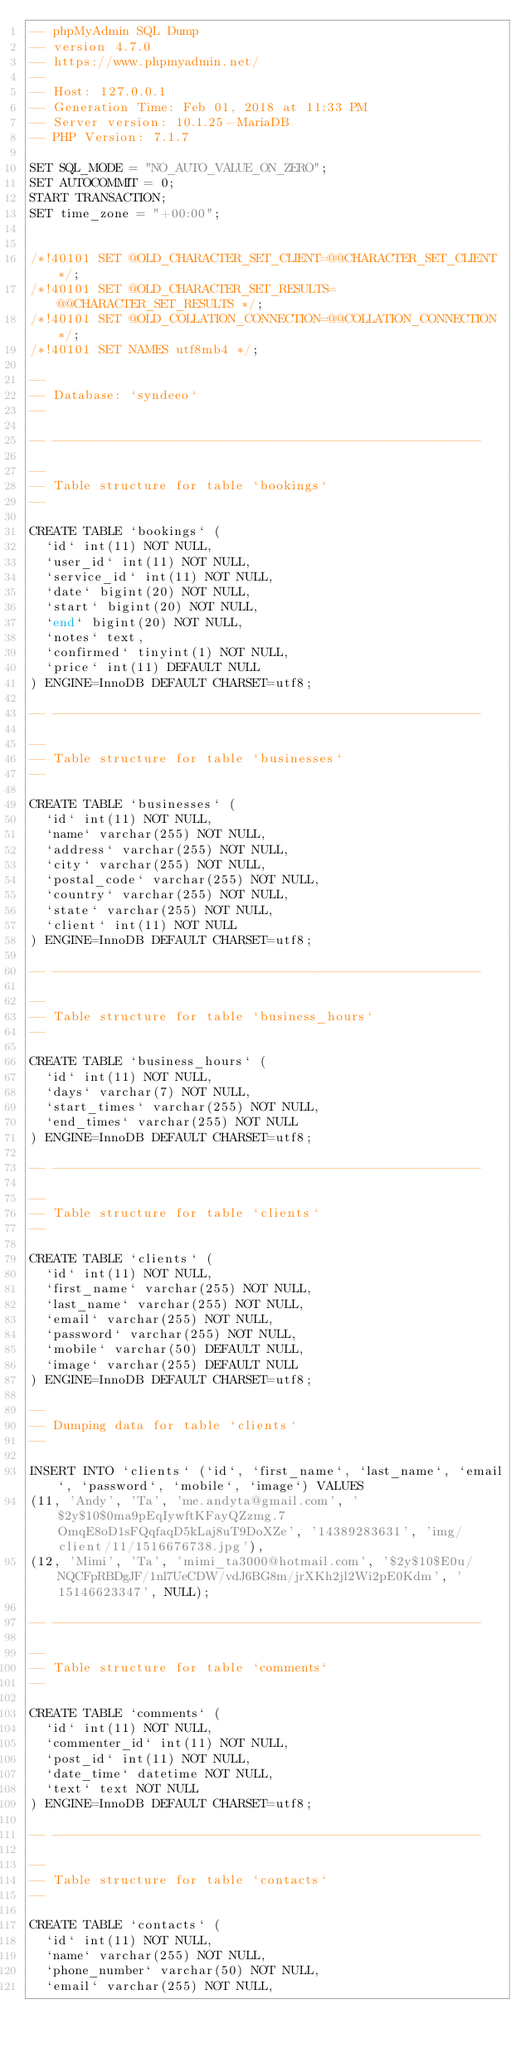Convert code to text. <code><loc_0><loc_0><loc_500><loc_500><_SQL_>-- phpMyAdmin SQL Dump
-- version 4.7.0
-- https://www.phpmyadmin.net/
--
-- Host: 127.0.0.1
-- Generation Time: Feb 01, 2018 at 11:33 PM
-- Server version: 10.1.25-MariaDB
-- PHP Version: 7.1.7

SET SQL_MODE = "NO_AUTO_VALUE_ON_ZERO";
SET AUTOCOMMIT = 0;
START TRANSACTION;
SET time_zone = "+00:00";


/*!40101 SET @OLD_CHARACTER_SET_CLIENT=@@CHARACTER_SET_CLIENT */;
/*!40101 SET @OLD_CHARACTER_SET_RESULTS=@@CHARACTER_SET_RESULTS */;
/*!40101 SET @OLD_COLLATION_CONNECTION=@@COLLATION_CONNECTION */;
/*!40101 SET NAMES utf8mb4 */;

--
-- Database: `syndeeo`
--

-- --------------------------------------------------------

--
-- Table structure for table `bookings`
--

CREATE TABLE `bookings` (
  `id` int(11) NOT NULL,
  `user_id` int(11) NOT NULL,
  `service_id` int(11) NOT NULL,
  `date` bigint(20) NOT NULL,
  `start` bigint(20) NOT NULL,
  `end` bigint(20) NOT NULL,
  `notes` text,
  `confirmed` tinyint(1) NOT NULL,
  `price` int(11) DEFAULT NULL
) ENGINE=InnoDB DEFAULT CHARSET=utf8;

-- --------------------------------------------------------

--
-- Table structure for table `businesses`
--

CREATE TABLE `businesses` (
  `id` int(11) NOT NULL,
  `name` varchar(255) NOT NULL,
  `address` varchar(255) NOT NULL,
  `city` varchar(255) NOT NULL,
  `postal_code` varchar(255) NOT NULL,
  `country` varchar(255) NOT NULL,
  `state` varchar(255) NOT NULL,
  `client` int(11) NOT NULL
) ENGINE=InnoDB DEFAULT CHARSET=utf8;

-- --------------------------------------------------------

--
-- Table structure for table `business_hours`
--

CREATE TABLE `business_hours` (
  `id` int(11) NOT NULL,
  `days` varchar(7) NOT NULL,
  `start_times` varchar(255) NOT NULL,
  `end_times` varchar(255) NOT NULL
) ENGINE=InnoDB DEFAULT CHARSET=utf8;

-- --------------------------------------------------------

--
-- Table structure for table `clients`
--

CREATE TABLE `clients` (
  `id` int(11) NOT NULL,
  `first_name` varchar(255) NOT NULL,
  `last_name` varchar(255) NOT NULL,
  `email` varchar(255) NOT NULL,
  `password` varchar(255) NOT NULL,
  `mobile` varchar(50) DEFAULT NULL,
  `image` varchar(255) DEFAULT NULL
) ENGINE=InnoDB DEFAULT CHARSET=utf8;

--
-- Dumping data for table `clients`
--

INSERT INTO `clients` (`id`, `first_name`, `last_name`, `email`, `password`, `mobile`, `image`) VALUES
(11, 'Andy', 'Ta', 'me.andyta@gmail.com', '$2y$10$0ma9pEqIywftKFayQZzmg.7OmqE8oD1sFQqfaqD5kLaj8uT9DoXZe', '14389283631', 'img/client/11/1516676738.jpg'),
(12, 'Mimi', 'Ta', 'mimi_ta3000@hotmail.com', '$2y$10$E0u/NQCFpRBDgJF/1nl7UeCDW/vdJ6BG8m/jrXKh2jl2Wi2pE0Kdm', '15146623347', NULL);

-- --------------------------------------------------------

--
-- Table structure for table `comments`
--

CREATE TABLE `comments` (
  `id` int(11) NOT NULL,
  `commenter_id` int(11) NOT NULL,
  `post_id` int(11) NOT NULL,
  `date_time` datetime NOT NULL,
  `text` text NOT NULL
) ENGINE=InnoDB DEFAULT CHARSET=utf8;

-- --------------------------------------------------------

--
-- Table structure for table `contacts`
--

CREATE TABLE `contacts` (
  `id` int(11) NOT NULL,
  `name` varchar(255) NOT NULL,
  `phone_number` varchar(50) NOT NULL,
  `email` varchar(255) NOT NULL,</code> 